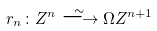Convert formula to latex. <formula><loc_0><loc_0><loc_500><loc_500>r _ { n } \colon Z ^ { n } \stackrel { \sim } { \longrightarrow } \Omega Z ^ { n + 1 }</formula> 